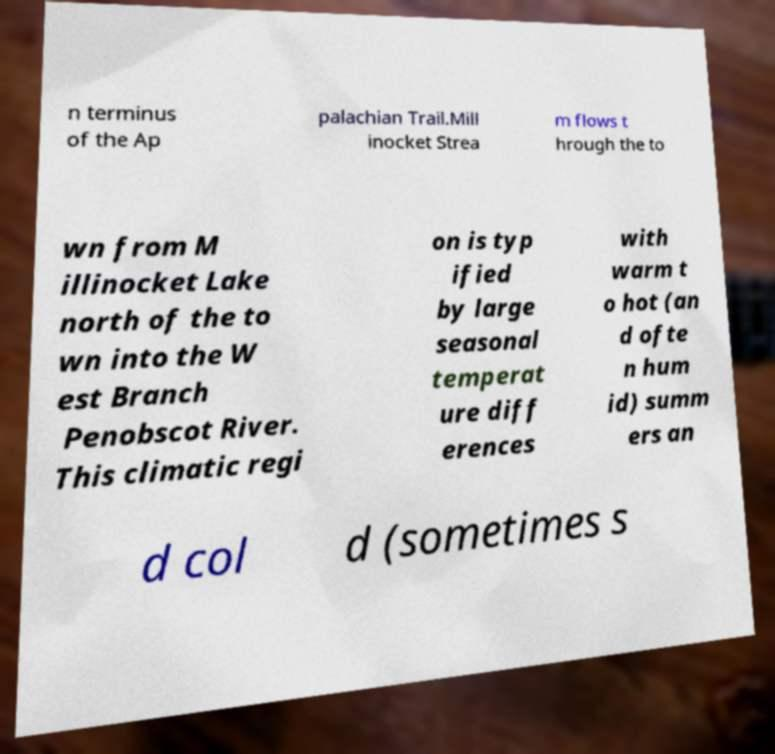Could you assist in decoding the text presented in this image and type it out clearly? n terminus of the Ap palachian Trail.Mill inocket Strea m flows t hrough the to wn from M illinocket Lake north of the to wn into the W est Branch Penobscot River. This climatic regi on is typ ified by large seasonal temperat ure diff erences with warm t o hot (an d ofte n hum id) summ ers an d col d (sometimes s 